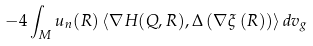Convert formula to latex. <formula><loc_0><loc_0><loc_500><loc_500>- 4 \int _ { M } u _ { n } ( R ) \left \langle \nabla H ( Q , R ) , \Delta \left ( \nabla \xi \left ( R \right ) \right ) \right \rangle d v _ { g }</formula> 